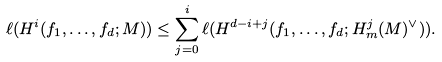Convert formula to latex. <formula><loc_0><loc_0><loc_500><loc_500>\ell ( H ^ { i } ( f _ { 1 } , \dots , f _ { d } ; M ) ) \leq \sum _ { j = 0 } ^ { i } \ell ( H ^ { d - i + j } ( f _ { 1 } , \dots , f _ { d } ; H ^ { j } _ { m } ( M ) ^ { \vee } ) ) .</formula> 